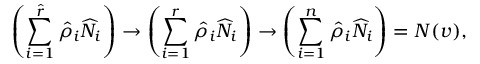Convert formula to latex. <formula><loc_0><loc_0><loc_500><loc_500>\left ( \sum _ { i = 1 } ^ { { \hat { r } } } { \hat { \rho } } _ { i } { \widehat { N } } _ { i } \right ) \to \left ( \sum _ { i = 1 } ^ { r } { \hat { \rho } } _ { i } { \widehat { N } } _ { i } \right ) \to \left ( \sum _ { i = 1 } ^ { n } { \hat { \rho } } _ { i } { \widehat { N } } _ { i } \right ) = N ( v ) ,</formula> 